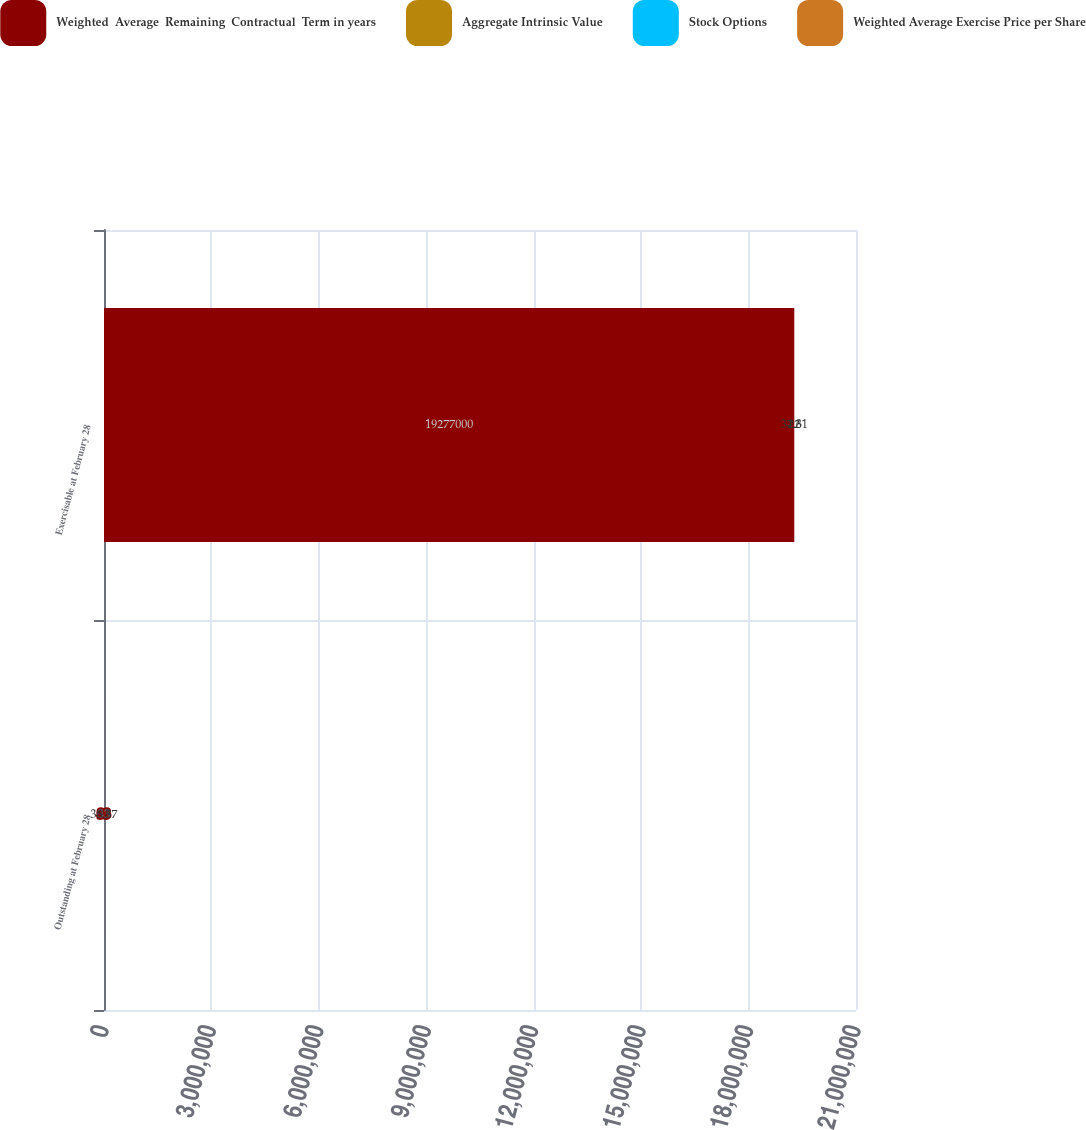Convert chart to OTSL. <chart><loc_0><loc_0><loc_500><loc_500><stacked_bar_chart><ecel><fcel>Outstanding at February 28<fcel>Exercisable at February 28<nl><fcel>Weighted  Average  Remaining  Contractual  Term in years<fcel>33<fcel>1.9277e+07<nl><fcel>Aggregate Intrinsic Value<fcel>38.37<fcel>37.31<nl><fcel>Stock Options<fcel>6.8<fcel>4.6<nl><fcel>Weighted Average Exercise Price per Share<fcel>33<fcel>22<nl></chart> 